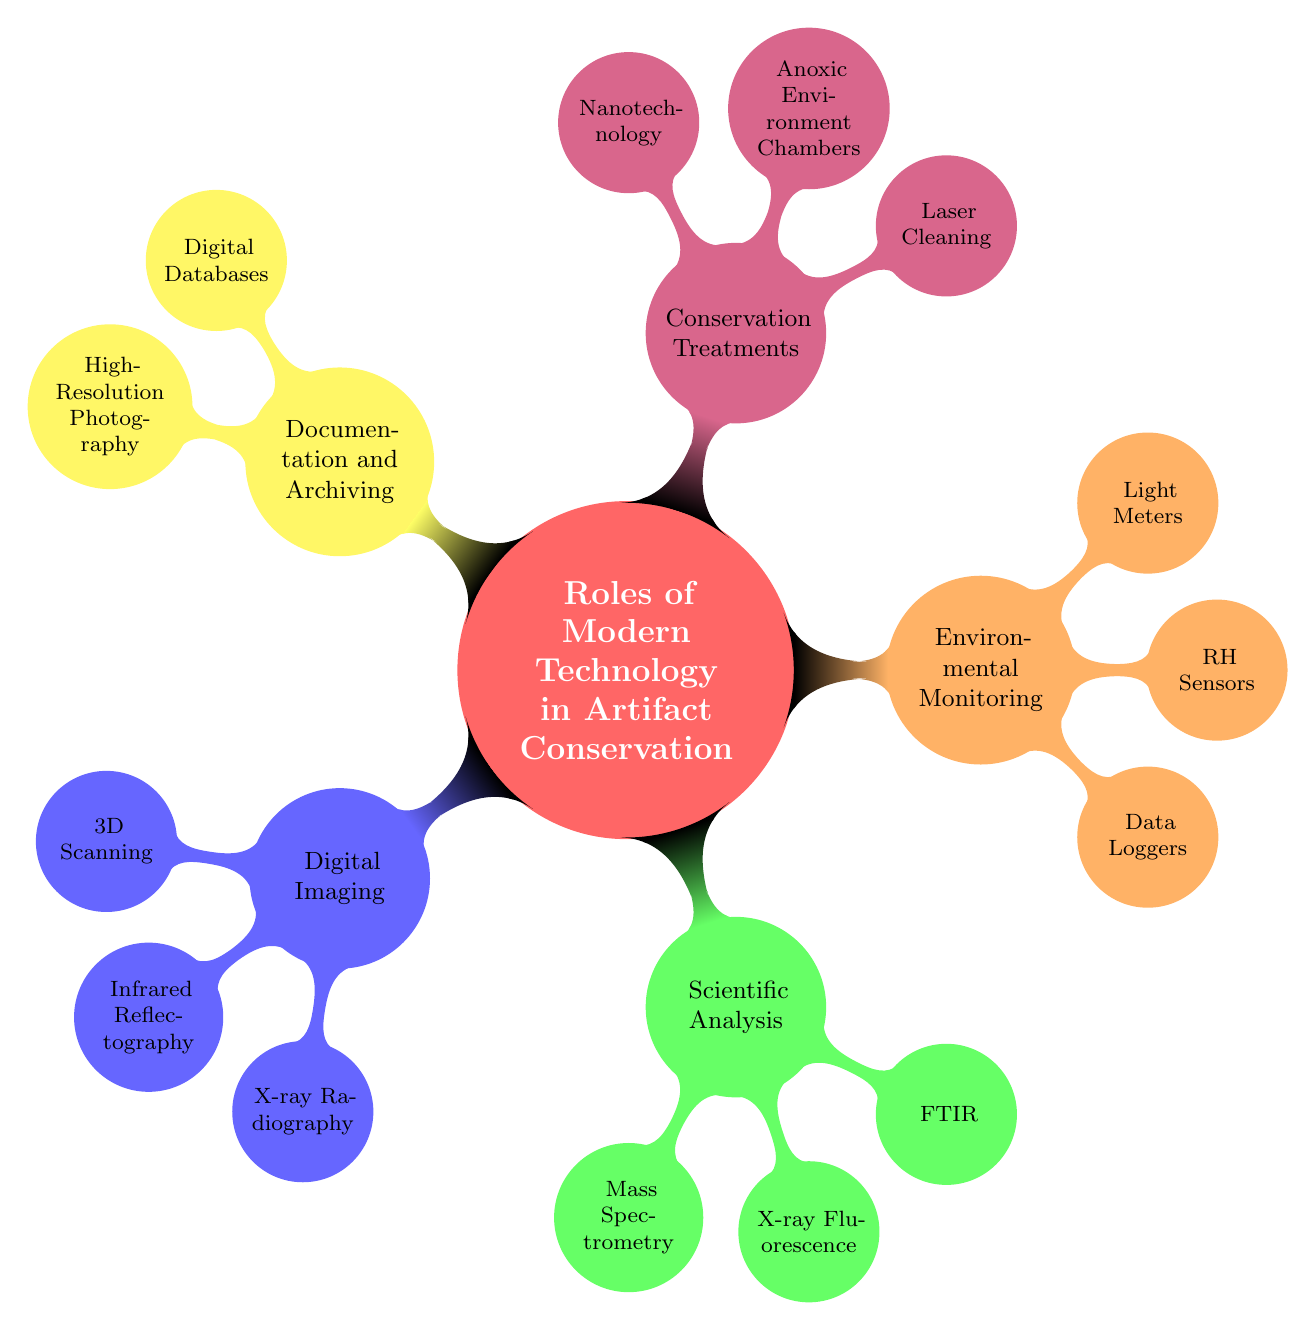What are the main categories of technology in artifact conservation? The diagram has five main categories: Digital Imaging, Scientific Analysis, Environmental Monitoring, Conservation Treatments, and Documentation and Archiving.
Answer: Digital Imaging, Scientific Analysis, Environmental Monitoring, Conservation Treatments, Documentation and Archiving How many sub-nodes does the 'Environmental Monitoring' category have? Under the 'Environmental Monitoring' category, there are three sub-nodes listed: Data Loggers, RH Sensors, and Light Meters.
Answer: 3 Which technology is used for identifying the chemical composition of artifacts? The sub-node under 'Scientific Analysis' that identifies the chemical composition of artifacts is called Mass Spectrometry.
Answer: Mass Spectrometry What does Infrared Reflectography help unveil? Infrared Reflectography, under the Digital Imaging category, is stated to help in uncovering layers beneath the surface.
Answer: Layers beneath the surface Which treatment method uses nanoparticles for conservation? The conservation method that mentions the use of nanoparticles for strengthened conservation treatments is called Nanotechnology.
Answer: Nanotechnology How many treatments are listed under 'Conservation Treatments'? The 'Conservation Treatments' category has three treatments listed: Laser Cleaning, Anoxic Environment Chambers, and Nanotechnology.
Answer: 3 What role do Data Loggers play in artifact conservation? Data Loggers, as indicated in the Environmental Monitoring section, track temperature and humidity levels, which is crucial for preserving artifacts.
Answer: Track temperature and humidity levels What technology measures exposure to harmful light levels? The technology that measures exposure to harmful light levels is identified as Light Meters, found in the Environmental Monitoring category.
Answer: Light Meters Which imaging technique reveals internal structures of artifacts? The imaging technique that reveals internal structures without damaging artifacts is X-ray Radiography, listed under Digital Imaging.
Answer: X-ray Radiography 